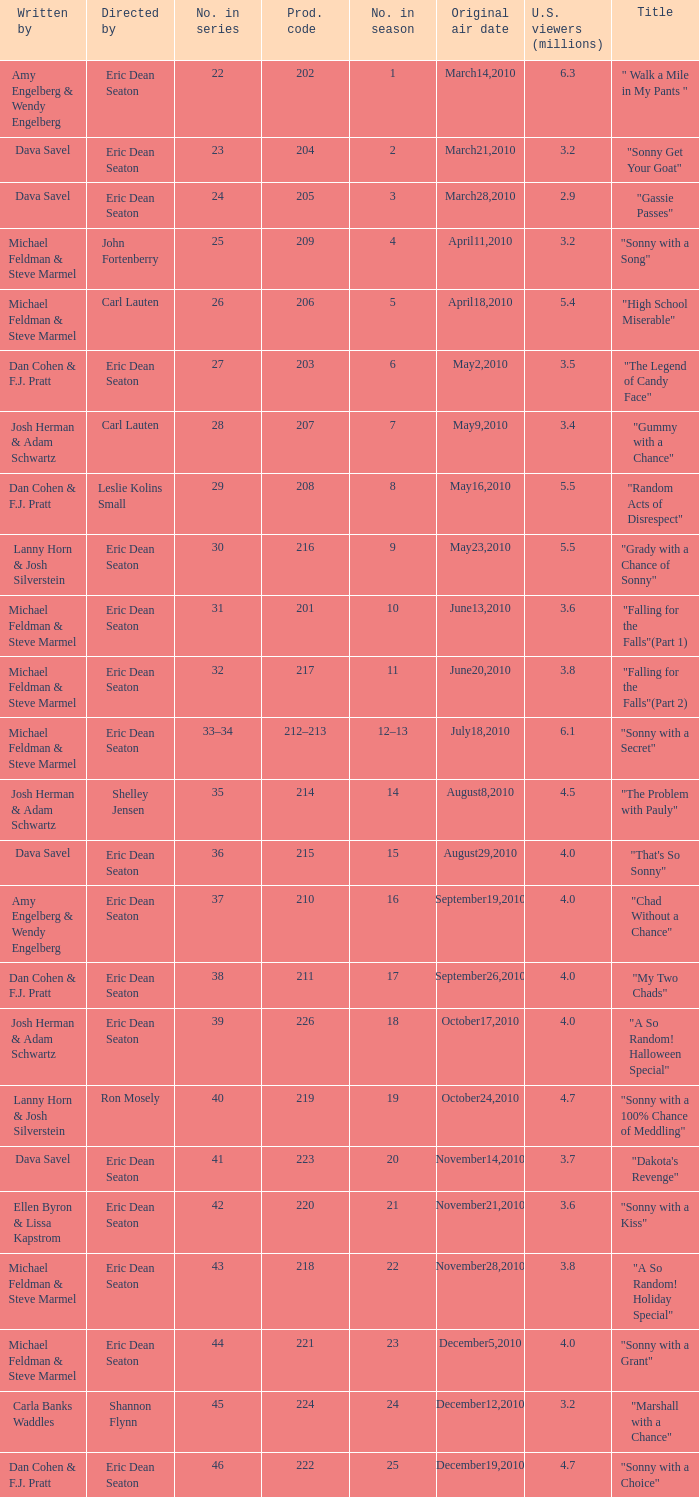How man episodes in the season were titled "that's so sonny"? 1.0. 